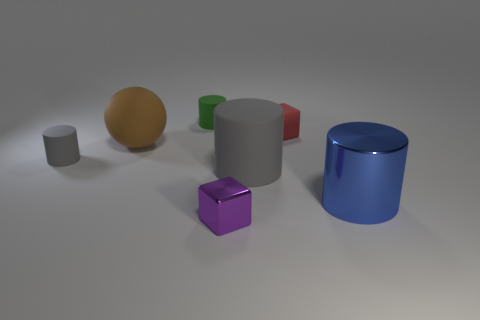There is a matte object that is the same color as the big rubber cylinder; what shape is it?
Ensure brevity in your answer.  Cylinder. The rubber cylinder right of the thing that is in front of the metallic thing that is on the right side of the small red thing is what color?
Ensure brevity in your answer.  Gray. There is a rubber cylinder that is to the right of the brown rubber ball and in front of the red rubber object; how big is it?
Provide a short and direct response. Large. What number of other objects are there of the same shape as the tiny red matte object?
Provide a succinct answer. 1. What number of cylinders are either large green objects or red objects?
Provide a succinct answer. 0. There is a brown sphere that is behind the large cylinder on the right side of the big gray thing; is there a blue metallic cylinder to the left of it?
Your response must be concise. No. There is a big metallic object that is the same shape as the big gray rubber thing; what is its color?
Give a very brief answer. Blue. What number of green objects are either tiny metal objects or big shiny blocks?
Your answer should be very brief. 0. What is the gray object that is to the left of the tiny cylinder behind the brown rubber object made of?
Offer a terse response. Rubber. Is the shape of the blue object the same as the small purple shiny object?
Offer a terse response. No. 